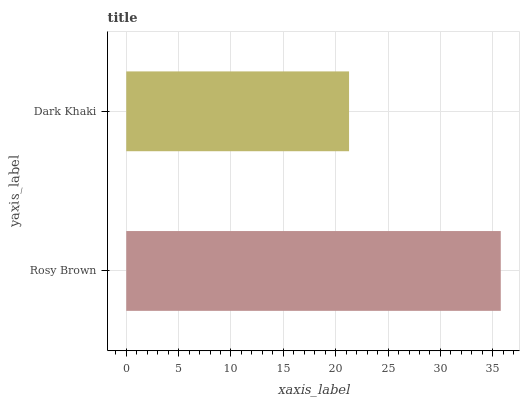Is Dark Khaki the minimum?
Answer yes or no. Yes. Is Rosy Brown the maximum?
Answer yes or no. Yes. Is Dark Khaki the maximum?
Answer yes or no. No. Is Rosy Brown greater than Dark Khaki?
Answer yes or no. Yes. Is Dark Khaki less than Rosy Brown?
Answer yes or no. Yes. Is Dark Khaki greater than Rosy Brown?
Answer yes or no. No. Is Rosy Brown less than Dark Khaki?
Answer yes or no. No. Is Rosy Brown the high median?
Answer yes or no. Yes. Is Dark Khaki the low median?
Answer yes or no. Yes. Is Dark Khaki the high median?
Answer yes or no. No. Is Rosy Brown the low median?
Answer yes or no. No. 